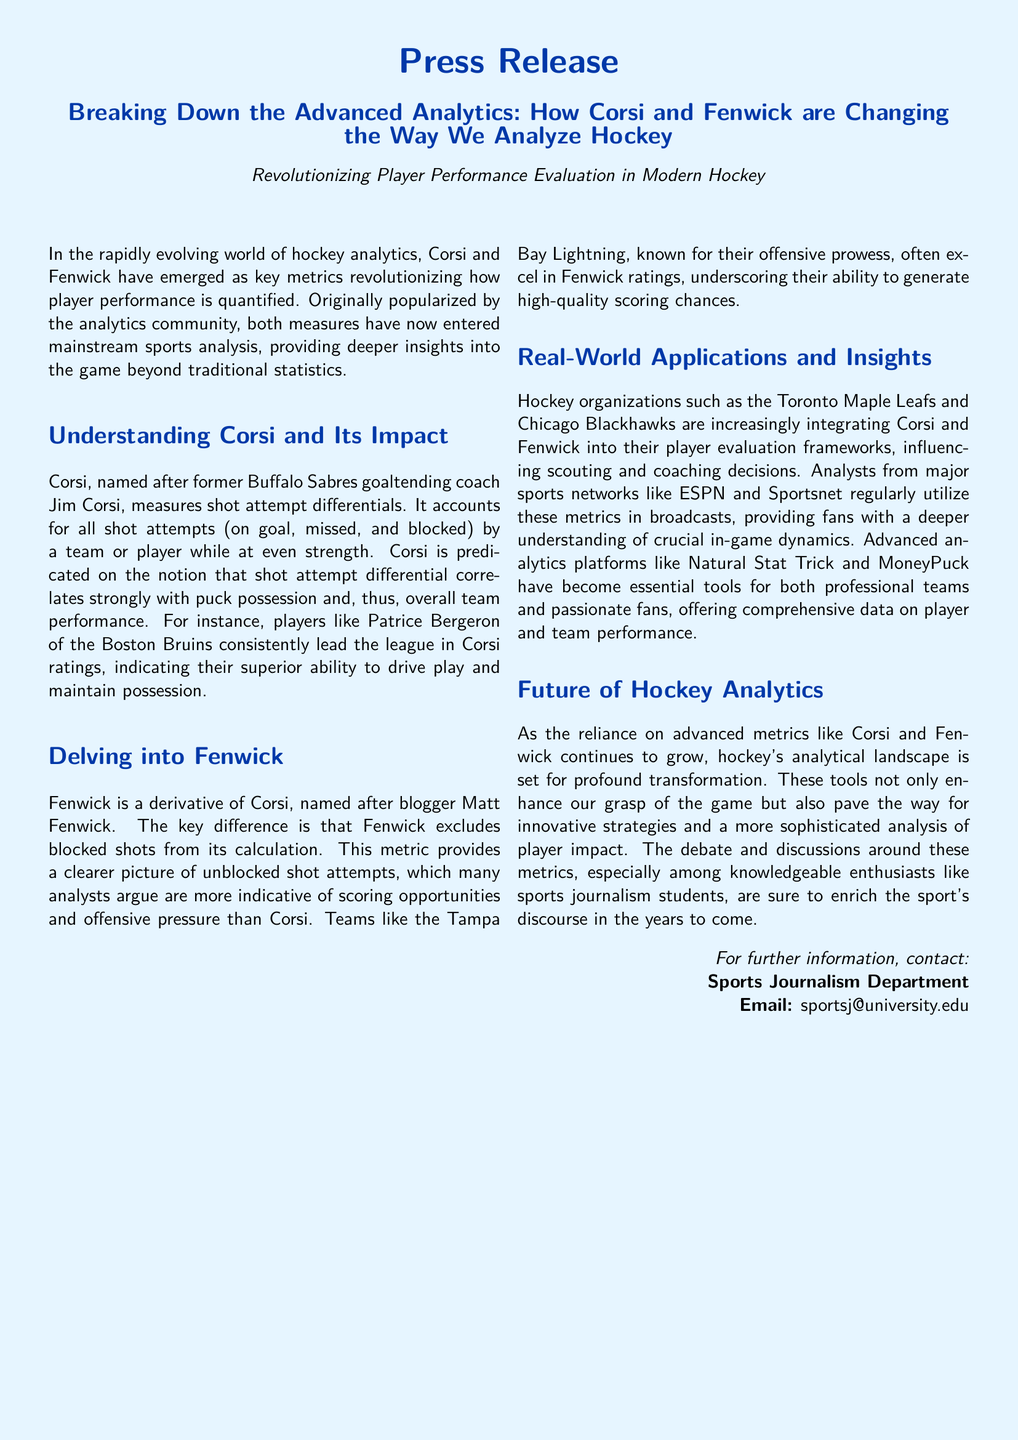What are Corsi and Fenwick? Corsi and Fenwick are advanced analytics metrics used to evaluate player performance in hockey.
Answer: Advanced analytics metrics Who is Corsi named after? Corsi is named after former Buffalo Sabres goaltending coach Jim Corsi.
Answer: Jim Corsi What does Corsi measure? Corsi measures shot attempt differentials, accounting for all shot attempts by a team or player at even strength.
Answer: Shot attempt differentials Which player is mentioned as consistently leading in Corsi ratings? Patrice Bergeron of the Boston Bruins is mentioned as consistently leading in Corsi ratings.
Answer: Patrice Bergeron What does Fenwick exclude from its calculation? Fenwick excludes blocked shots from its calculation.
Answer: Blocked shots Which teams are noted for integrating Corsi and Fenwick? The Toronto Maple Leafs and Chicago Blackhawks are noted for integrating Corsi and Fenwick.
Answer: Toronto Maple Leafs and Chicago Blackhawks What type of organizations use advanced analytics like Corsi and Fenwick? Hockey organizations such as professional teams and analysts from major sports networks use advanced analytics.
Answer: Professional teams and analysts How do Corsi and Fenwick impact hockey analytics? Corsi and Fenwick enhance understanding of the game and influence scouting and coaching decisions.
Answer: Influence scouting and coaching decisions What is the significance of Corsi and Fenwick in modern hockey? They provide deeper insights into the game beyond traditional statistics.
Answer: Deeper insights 